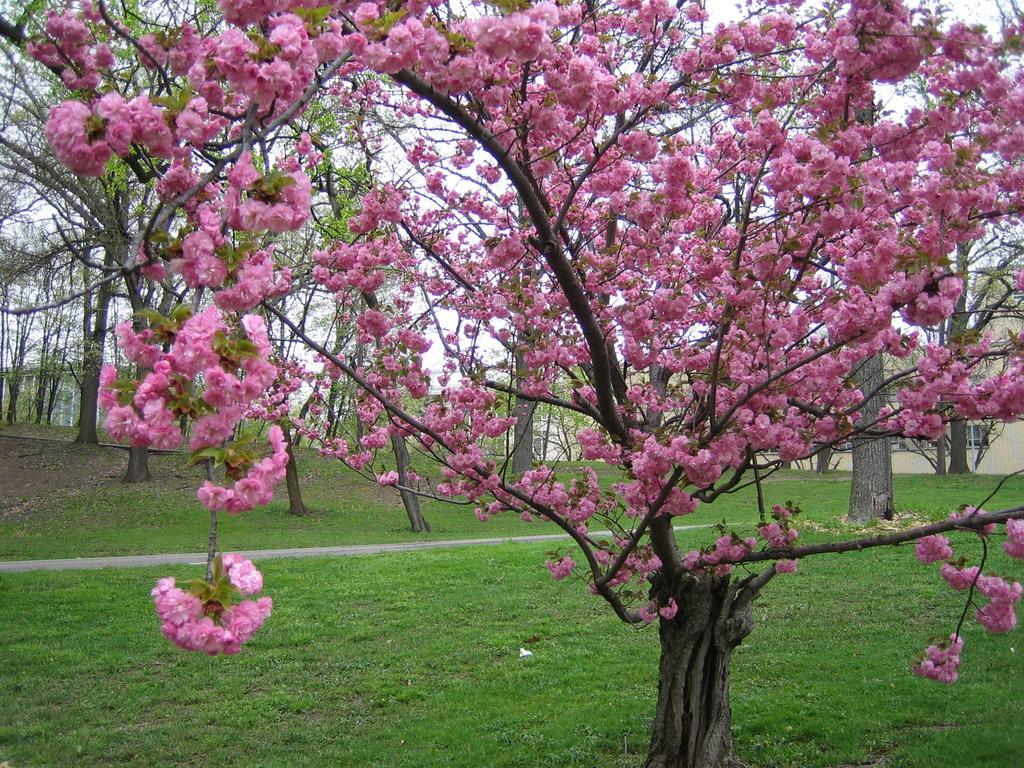In one or two sentences, can you explain what this image depicts? In the foreground of this image, there is a tree on the grass. In the background, there are few trees, buildings and the sky. 